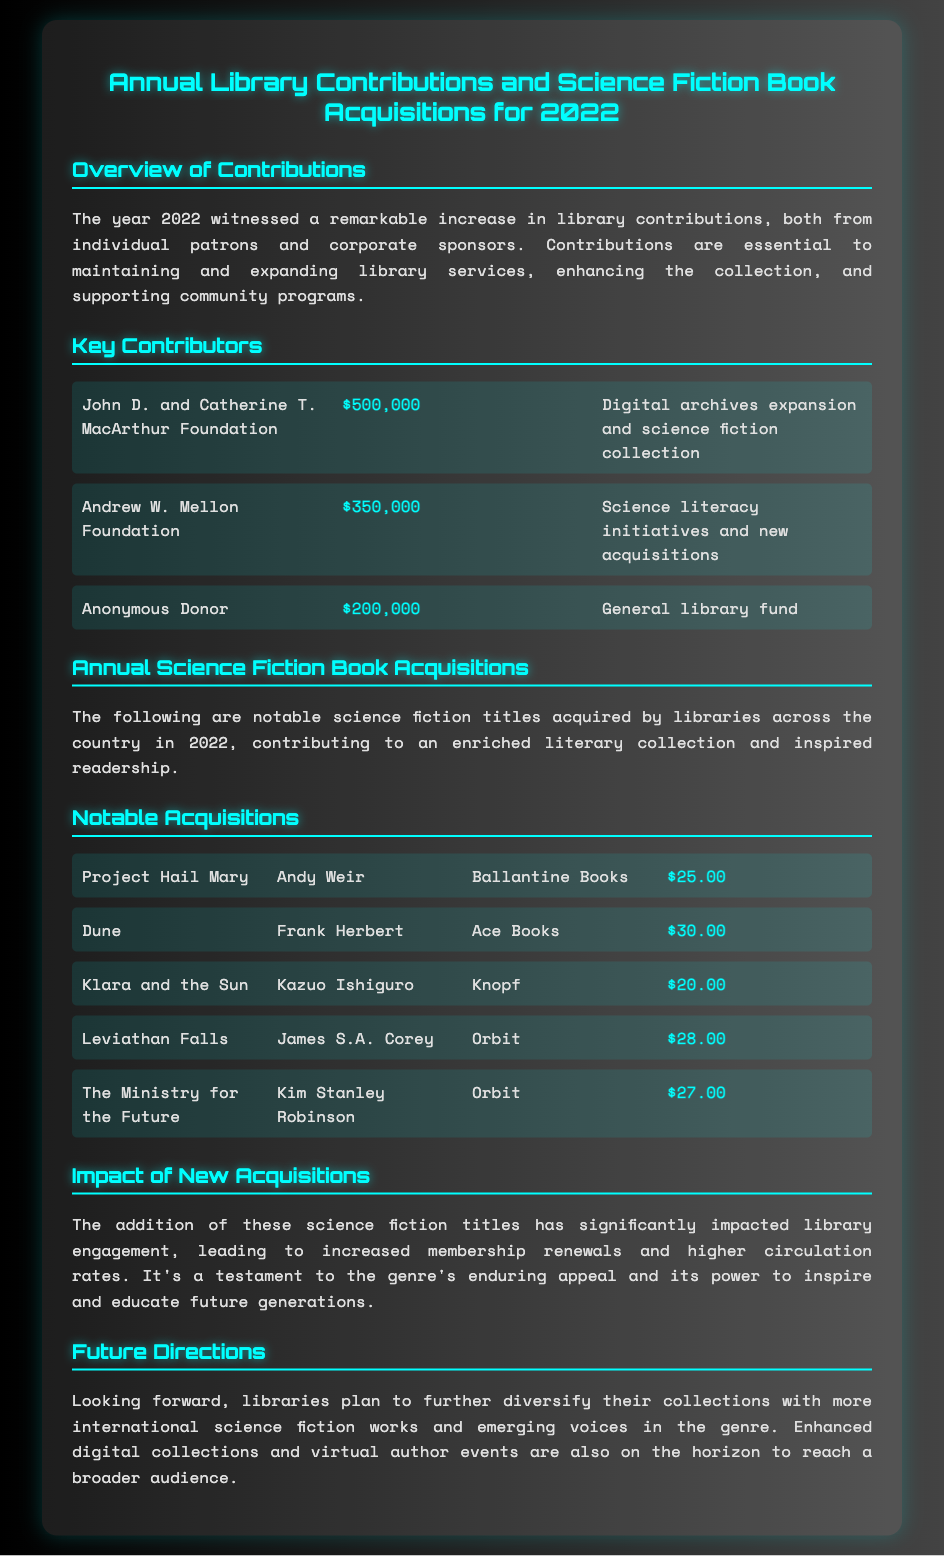What was the total contribution from the John D. and Catherine T. MacArthur Foundation? The total contribution from the foundation is listed in the document as $500,000.
Answer: $500,000 How many notable science fiction titles were acquired by libraries in 2022? The document lists five notable acquisitions under the "Notable Acquisitions" section.
Answer: Five What genre significantly impacted library engagement according to the document? The genre mentioned that significantly impacted engagement is science fiction.
Answer: Science fiction What was the cost of "The Ministry for the Future"? The document states that "The Ministry for the Future" costs $27.00.
Answer: $27.00 Which foundation contributed to the science literacy initiatives? The foundation that contributed to science literacy initiatives is the Andrew W. Mellon Foundation.
Answer: Andrew W. Mellon Foundation What will libraries focus on in their future directions? The document suggests that libraries will focus on diversifying their collections with international science fiction works.
Answer: Diversifying collections What is one key area of expansion mentioned in the overview of contributions? The key area of expansion mentioned is digital archives.
Answer: Digital archives What purchased book had the highest cost? "Dune" had the highest cost listed at $30.00.
Answer: Dune Who is the author of "Klara and the Sun"? The author of "Klara and the Sun" is Kazuo Ishiguro.
Answer: Kazuo Ishiguro 